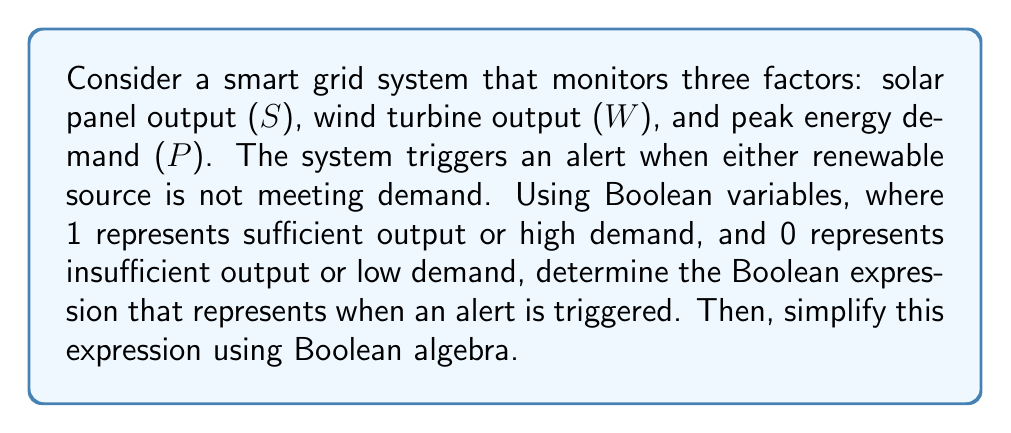What is the answer to this math problem? Let's approach this step-by-step:

1) First, we need to define when an alert is triggered. It occurs when:
   - Solar output is insufficient (S = 0) AND peak demand is high (P = 1)
   OR
   - Wind output is insufficient (W = 0) AND peak demand is high (P = 1)

2) We can express this in Boolean algebra as:
   $$((\overline{S} \cdot P) + (\overline{W} \cdot P))$$

3) Let's simplify this expression:
   $$(\overline{S} \cdot P) + (\overline{W} \cdot P)$$
   $$= P \cdot (\overline{S} + \overline{W})$$ (factoring out P using the distributive law)

4) We can simplify further using De Morgan's law:
   $$P \cdot (\overline{S} + \overline{W}) = P \cdot \overline{(S \cdot W)}$$

5) This simplified expression means an alert is triggered when peak demand is high (P = 1) AND either solar OR wind output is insufficient (not both S AND W are sufficient).

This Boolean expression allows for efficient analysis of energy consumption patterns and helps identify when renewable sources are not meeting demand, which is crucial information for advocating for renewable energy subsidies.
Answer: $$P \cdot \overline{(S \cdot W)}$$ 